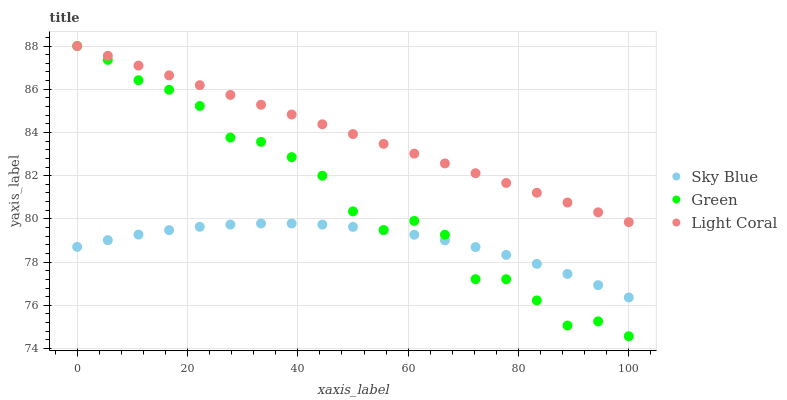Does Sky Blue have the minimum area under the curve?
Answer yes or no. Yes. Does Light Coral have the maximum area under the curve?
Answer yes or no. Yes. Does Green have the minimum area under the curve?
Answer yes or no. No. Does Green have the maximum area under the curve?
Answer yes or no. No. Is Light Coral the smoothest?
Answer yes or no. Yes. Is Green the roughest?
Answer yes or no. Yes. Is Sky Blue the smoothest?
Answer yes or no. No. Is Sky Blue the roughest?
Answer yes or no. No. Does Green have the lowest value?
Answer yes or no. Yes. Does Sky Blue have the lowest value?
Answer yes or no. No. Does Green have the highest value?
Answer yes or no. Yes. Does Sky Blue have the highest value?
Answer yes or no. No. Is Sky Blue less than Light Coral?
Answer yes or no. Yes. Is Light Coral greater than Sky Blue?
Answer yes or no. Yes. Does Green intersect Sky Blue?
Answer yes or no. Yes. Is Green less than Sky Blue?
Answer yes or no. No. Is Green greater than Sky Blue?
Answer yes or no. No. Does Sky Blue intersect Light Coral?
Answer yes or no. No. 